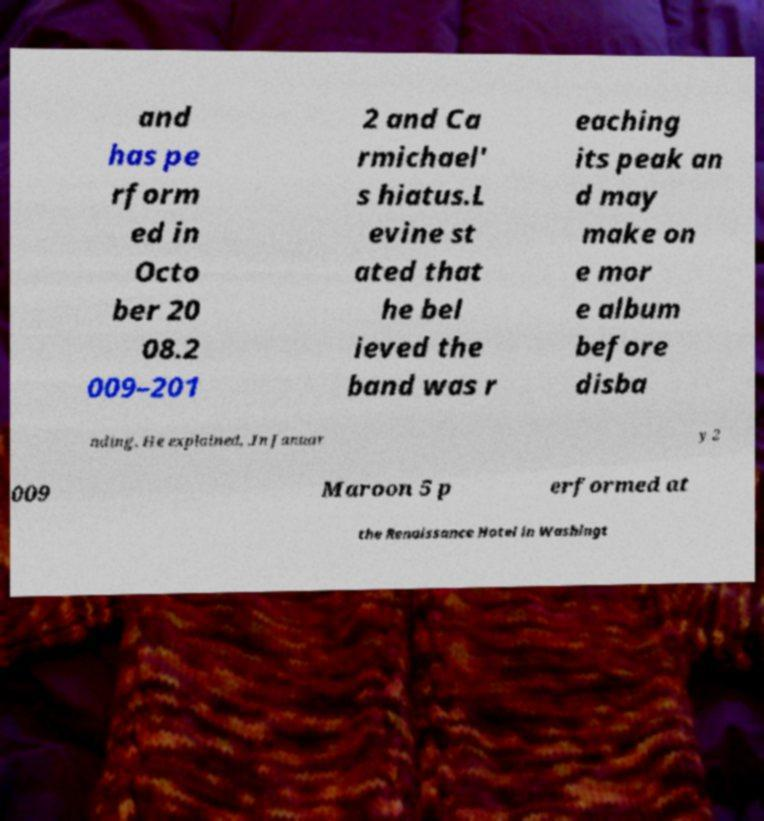Can you accurately transcribe the text from the provided image for me? and has pe rform ed in Octo ber 20 08.2 009–201 2 and Ca rmichael' s hiatus.L evine st ated that he bel ieved the band was r eaching its peak an d may make on e mor e album before disba nding. He explained, .In Januar y 2 009 Maroon 5 p erformed at the Renaissance Hotel in Washingt 